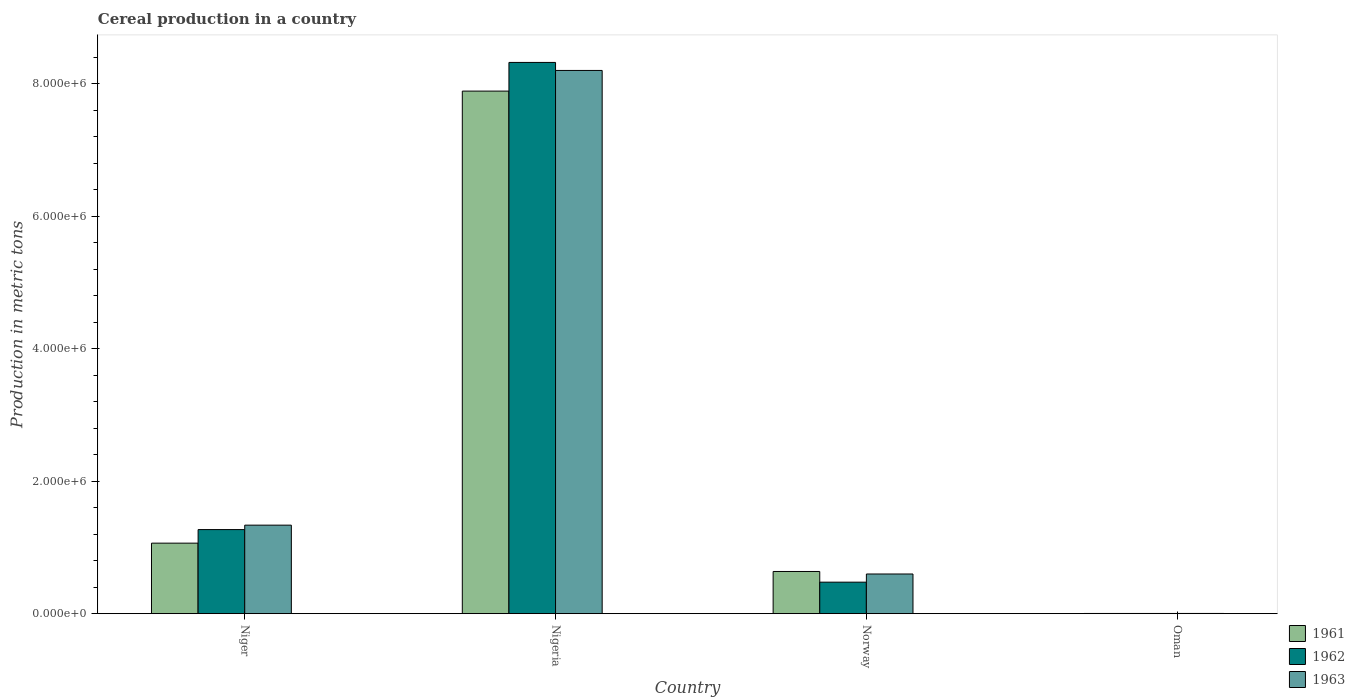How many groups of bars are there?
Offer a very short reply. 4. Are the number of bars per tick equal to the number of legend labels?
Your response must be concise. Yes. How many bars are there on the 1st tick from the left?
Offer a terse response. 3. What is the label of the 4th group of bars from the left?
Your answer should be very brief. Oman. In how many cases, is the number of bars for a given country not equal to the number of legend labels?
Provide a succinct answer. 0. What is the total cereal production in 1962 in Norway?
Provide a short and direct response. 4.75e+05. Across all countries, what is the maximum total cereal production in 1961?
Ensure brevity in your answer.  7.89e+06. Across all countries, what is the minimum total cereal production in 1962?
Ensure brevity in your answer.  2900. In which country was the total cereal production in 1962 maximum?
Give a very brief answer. Nigeria. In which country was the total cereal production in 1962 minimum?
Provide a succinct answer. Oman. What is the total total cereal production in 1961 in the graph?
Keep it short and to the point. 9.60e+06. What is the difference between the total cereal production in 1963 in Niger and that in Nigeria?
Offer a terse response. -6.87e+06. What is the difference between the total cereal production in 1961 in Norway and the total cereal production in 1962 in Oman?
Provide a short and direct response. 6.34e+05. What is the average total cereal production in 1962 per country?
Make the answer very short. 2.52e+06. What is the difference between the total cereal production of/in 1961 and total cereal production of/in 1963 in Niger?
Offer a very short reply. -2.72e+05. In how many countries, is the total cereal production in 1961 greater than 3200000 metric tons?
Offer a terse response. 1. What is the ratio of the total cereal production in 1961 in Norway to that in Oman?
Offer a terse response. 219.6. Is the difference between the total cereal production in 1961 in Niger and Oman greater than the difference between the total cereal production in 1963 in Niger and Oman?
Your answer should be compact. No. What is the difference between the highest and the second highest total cereal production in 1963?
Your answer should be very brief. 6.87e+06. What is the difference between the highest and the lowest total cereal production in 1961?
Your response must be concise. 7.89e+06. What does the 3rd bar from the right in Niger represents?
Your answer should be compact. 1961. Are all the bars in the graph horizontal?
Ensure brevity in your answer.  No. How many countries are there in the graph?
Ensure brevity in your answer.  4. Does the graph contain any zero values?
Provide a succinct answer. No. Where does the legend appear in the graph?
Provide a succinct answer. Bottom right. How are the legend labels stacked?
Make the answer very short. Vertical. What is the title of the graph?
Your answer should be very brief. Cereal production in a country. What is the label or title of the Y-axis?
Your response must be concise. Production in metric tons. What is the Production in metric tons of 1961 in Niger?
Ensure brevity in your answer.  1.06e+06. What is the Production in metric tons in 1962 in Niger?
Your response must be concise. 1.27e+06. What is the Production in metric tons of 1963 in Niger?
Provide a short and direct response. 1.34e+06. What is the Production in metric tons in 1961 in Nigeria?
Offer a terse response. 7.89e+06. What is the Production in metric tons in 1962 in Nigeria?
Your answer should be very brief. 8.32e+06. What is the Production in metric tons of 1963 in Nigeria?
Provide a succinct answer. 8.20e+06. What is the Production in metric tons in 1961 in Norway?
Offer a terse response. 6.37e+05. What is the Production in metric tons of 1962 in Norway?
Give a very brief answer. 4.75e+05. What is the Production in metric tons in 1963 in Norway?
Offer a terse response. 5.99e+05. What is the Production in metric tons in 1961 in Oman?
Your answer should be compact. 2900. What is the Production in metric tons in 1962 in Oman?
Your answer should be compact. 2900. What is the Production in metric tons in 1963 in Oman?
Keep it short and to the point. 3000. Across all countries, what is the maximum Production in metric tons of 1961?
Provide a short and direct response. 7.89e+06. Across all countries, what is the maximum Production in metric tons in 1962?
Provide a succinct answer. 8.32e+06. Across all countries, what is the maximum Production in metric tons in 1963?
Give a very brief answer. 8.20e+06. Across all countries, what is the minimum Production in metric tons of 1961?
Your answer should be very brief. 2900. Across all countries, what is the minimum Production in metric tons of 1962?
Give a very brief answer. 2900. Across all countries, what is the minimum Production in metric tons of 1963?
Offer a very short reply. 3000. What is the total Production in metric tons in 1961 in the graph?
Your answer should be very brief. 9.60e+06. What is the total Production in metric tons of 1962 in the graph?
Provide a succinct answer. 1.01e+07. What is the total Production in metric tons of 1963 in the graph?
Provide a short and direct response. 1.01e+07. What is the difference between the Production in metric tons of 1961 in Niger and that in Nigeria?
Offer a terse response. -6.83e+06. What is the difference between the Production in metric tons of 1962 in Niger and that in Nigeria?
Make the answer very short. -7.05e+06. What is the difference between the Production in metric tons in 1963 in Niger and that in Nigeria?
Provide a short and direct response. -6.87e+06. What is the difference between the Production in metric tons in 1961 in Niger and that in Norway?
Provide a short and direct response. 4.28e+05. What is the difference between the Production in metric tons in 1962 in Niger and that in Norway?
Offer a very short reply. 7.94e+05. What is the difference between the Production in metric tons in 1963 in Niger and that in Norway?
Your answer should be compact. 7.38e+05. What is the difference between the Production in metric tons of 1961 in Niger and that in Oman?
Your answer should be compact. 1.06e+06. What is the difference between the Production in metric tons of 1962 in Niger and that in Oman?
Offer a very short reply. 1.27e+06. What is the difference between the Production in metric tons of 1963 in Niger and that in Oman?
Keep it short and to the point. 1.33e+06. What is the difference between the Production in metric tons in 1961 in Nigeria and that in Norway?
Your answer should be compact. 7.25e+06. What is the difference between the Production in metric tons of 1962 in Nigeria and that in Norway?
Provide a succinct answer. 7.85e+06. What is the difference between the Production in metric tons of 1963 in Nigeria and that in Norway?
Offer a terse response. 7.60e+06. What is the difference between the Production in metric tons of 1961 in Nigeria and that in Oman?
Offer a very short reply. 7.89e+06. What is the difference between the Production in metric tons of 1962 in Nigeria and that in Oman?
Offer a terse response. 8.32e+06. What is the difference between the Production in metric tons of 1963 in Nigeria and that in Oman?
Your answer should be very brief. 8.20e+06. What is the difference between the Production in metric tons in 1961 in Norway and that in Oman?
Keep it short and to the point. 6.34e+05. What is the difference between the Production in metric tons in 1962 in Norway and that in Oman?
Make the answer very short. 4.72e+05. What is the difference between the Production in metric tons of 1963 in Norway and that in Oman?
Offer a very short reply. 5.96e+05. What is the difference between the Production in metric tons in 1961 in Niger and the Production in metric tons in 1962 in Nigeria?
Make the answer very short. -7.26e+06. What is the difference between the Production in metric tons of 1961 in Niger and the Production in metric tons of 1963 in Nigeria?
Keep it short and to the point. -7.14e+06. What is the difference between the Production in metric tons of 1962 in Niger and the Production in metric tons of 1963 in Nigeria?
Make the answer very short. -6.93e+06. What is the difference between the Production in metric tons in 1961 in Niger and the Production in metric tons in 1962 in Norway?
Give a very brief answer. 5.89e+05. What is the difference between the Production in metric tons of 1961 in Niger and the Production in metric tons of 1963 in Norway?
Your answer should be compact. 4.66e+05. What is the difference between the Production in metric tons in 1962 in Niger and the Production in metric tons in 1963 in Norway?
Your answer should be very brief. 6.71e+05. What is the difference between the Production in metric tons in 1961 in Niger and the Production in metric tons in 1962 in Oman?
Make the answer very short. 1.06e+06. What is the difference between the Production in metric tons in 1961 in Niger and the Production in metric tons in 1963 in Oman?
Give a very brief answer. 1.06e+06. What is the difference between the Production in metric tons of 1962 in Niger and the Production in metric tons of 1963 in Oman?
Ensure brevity in your answer.  1.27e+06. What is the difference between the Production in metric tons of 1961 in Nigeria and the Production in metric tons of 1962 in Norway?
Give a very brief answer. 7.42e+06. What is the difference between the Production in metric tons in 1961 in Nigeria and the Production in metric tons in 1963 in Norway?
Make the answer very short. 7.29e+06. What is the difference between the Production in metric tons of 1962 in Nigeria and the Production in metric tons of 1963 in Norway?
Ensure brevity in your answer.  7.73e+06. What is the difference between the Production in metric tons in 1961 in Nigeria and the Production in metric tons in 1962 in Oman?
Offer a very short reply. 7.89e+06. What is the difference between the Production in metric tons of 1961 in Nigeria and the Production in metric tons of 1963 in Oman?
Offer a terse response. 7.89e+06. What is the difference between the Production in metric tons of 1962 in Nigeria and the Production in metric tons of 1963 in Oman?
Your response must be concise. 8.32e+06. What is the difference between the Production in metric tons in 1961 in Norway and the Production in metric tons in 1962 in Oman?
Give a very brief answer. 6.34e+05. What is the difference between the Production in metric tons in 1961 in Norway and the Production in metric tons in 1963 in Oman?
Make the answer very short. 6.34e+05. What is the difference between the Production in metric tons of 1962 in Norway and the Production in metric tons of 1963 in Oman?
Offer a terse response. 4.72e+05. What is the average Production in metric tons in 1961 per country?
Offer a very short reply. 2.40e+06. What is the average Production in metric tons in 1962 per country?
Offer a very short reply. 2.52e+06. What is the average Production in metric tons in 1963 per country?
Offer a very short reply. 2.54e+06. What is the difference between the Production in metric tons in 1961 and Production in metric tons in 1962 in Niger?
Your answer should be very brief. -2.05e+05. What is the difference between the Production in metric tons in 1961 and Production in metric tons in 1963 in Niger?
Provide a succinct answer. -2.72e+05. What is the difference between the Production in metric tons of 1962 and Production in metric tons of 1963 in Niger?
Make the answer very short. -6.71e+04. What is the difference between the Production in metric tons in 1961 and Production in metric tons in 1962 in Nigeria?
Make the answer very short. -4.33e+05. What is the difference between the Production in metric tons in 1961 and Production in metric tons in 1963 in Nigeria?
Ensure brevity in your answer.  -3.12e+05. What is the difference between the Production in metric tons of 1962 and Production in metric tons of 1963 in Nigeria?
Ensure brevity in your answer.  1.21e+05. What is the difference between the Production in metric tons in 1961 and Production in metric tons in 1962 in Norway?
Give a very brief answer. 1.61e+05. What is the difference between the Production in metric tons in 1961 and Production in metric tons in 1963 in Norway?
Your answer should be very brief. 3.81e+04. What is the difference between the Production in metric tons of 1962 and Production in metric tons of 1963 in Norway?
Your answer should be very brief. -1.23e+05. What is the difference between the Production in metric tons in 1961 and Production in metric tons in 1962 in Oman?
Provide a short and direct response. 0. What is the difference between the Production in metric tons in 1961 and Production in metric tons in 1963 in Oman?
Offer a terse response. -100. What is the difference between the Production in metric tons of 1962 and Production in metric tons of 1963 in Oman?
Keep it short and to the point. -100. What is the ratio of the Production in metric tons in 1961 in Niger to that in Nigeria?
Keep it short and to the point. 0.13. What is the ratio of the Production in metric tons in 1962 in Niger to that in Nigeria?
Provide a succinct answer. 0.15. What is the ratio of the Production in metric tons of 1963 in Niger to that in Nigeria?
Offer a very short reply. 0.16. What is the ratio of the Production in metric tons of 1961 in Niger to that in Norway?
Provide a short and direct response. 1.67. What is the ratio of the Production in metric tons of 1962 in Niger to that in Norway?
Ensure brevity in your answer.  2.67. What is the ratio of the Production in metric tons in 1963 in Niger to that in Norway?
Make the answer very short. 2.23. What is the ratio of the Production in metric tons in 1961 in Niger to that in Oman?
Keep it short and to the point. 367.08. What is the ratio of the Production in metric tons of 1962 in Niger to that in Oman?
Keep it short and to the point. 437.72. What is the ratio of the Production in metric tons in 1963 in Niger to that in Oman?
Provide a short and direct response. 445.48. What is the ratio of the Production in metric tons in 1961 in Nigeria to that in Norway?
Give a very brief answer. 12.39. What is the ratio of the Production in metric tons in 1962 in Nigeria to that in Norway?
Provide a short and direct response. 17.51. What is the ratio of the Production in metric tons of 1963 in Nigeria to that in Norway?
Provide a short and direct response. 13.7. What is the ratio of the Production in metric tons of 1961 in Nigeria to that in Oman?
Give a very brief answer. 2721.03. What is the ratio of the Production in metric tons of 1962 in Nigeria to that in Oman?
Provide a short and direct response. 2870.34. What is the ratio of the Production in metric tons of 1963 in Nigeria to that in Oman?
Keep it short and to the point. 2734.33. What is the ratio of the Production in metric tons of 1961 in Norway to that in Oman?
Provide a short and direct response. 219.6. What is the ratio of the Production in metric tons of 1962 in Norway to that in Oman?
Provide a succinct answer. 163.93. What is the ratio of the Production in metric tons in 1963 in Norway to that in Oman?
Offer a terse response. 199.58. What is the difference between the highest and the second highest Production in metric tons in 1961?
Your answer should be very brief. 6.83e+06. What is the difference between the highest and the second highest Production in metric tons in 1962?
Your answer should be very brief. 7.05e+06. What is the difference between the highest and the second highest Production in metric tons of 1963?
Make the answer very short. 6.87e+06. What is the difference between the highest and the lowest Production in metric tons in 1961?
Your response must be concise. 7.89e+06. What is the difference between the highest and the lowest Production in metric tons in 1962?
Ensure brevity in your answer.  8.32e+06. What is the difference between the highest and the lowest Production in metric tons of 1963?
Ensure brevity in your answer.  8.20e+06. 